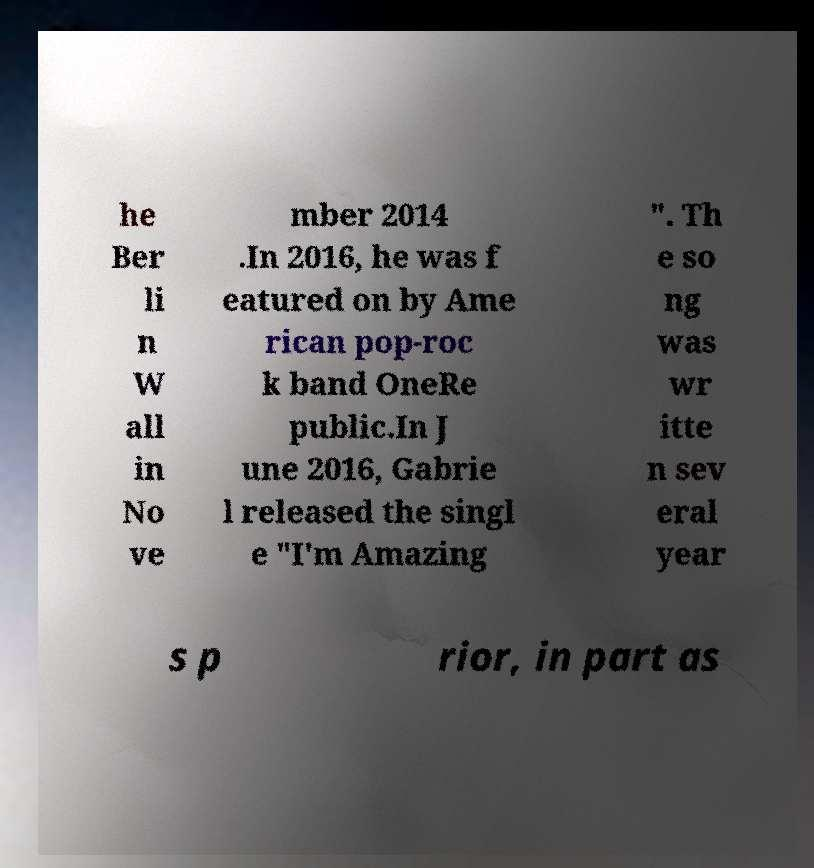Could you assist in decoding the text presented in this image and type it out clearly? he Ber li n W all in No ve mber 2014 .In 2016, he was f eatured on by Ame rican pop-roc k band OneRe public.In J une 2016, Gabrie l released the singl e "I'm Amazing ". Th e so ng was wr itte n sev eral year s p rior, in part as 